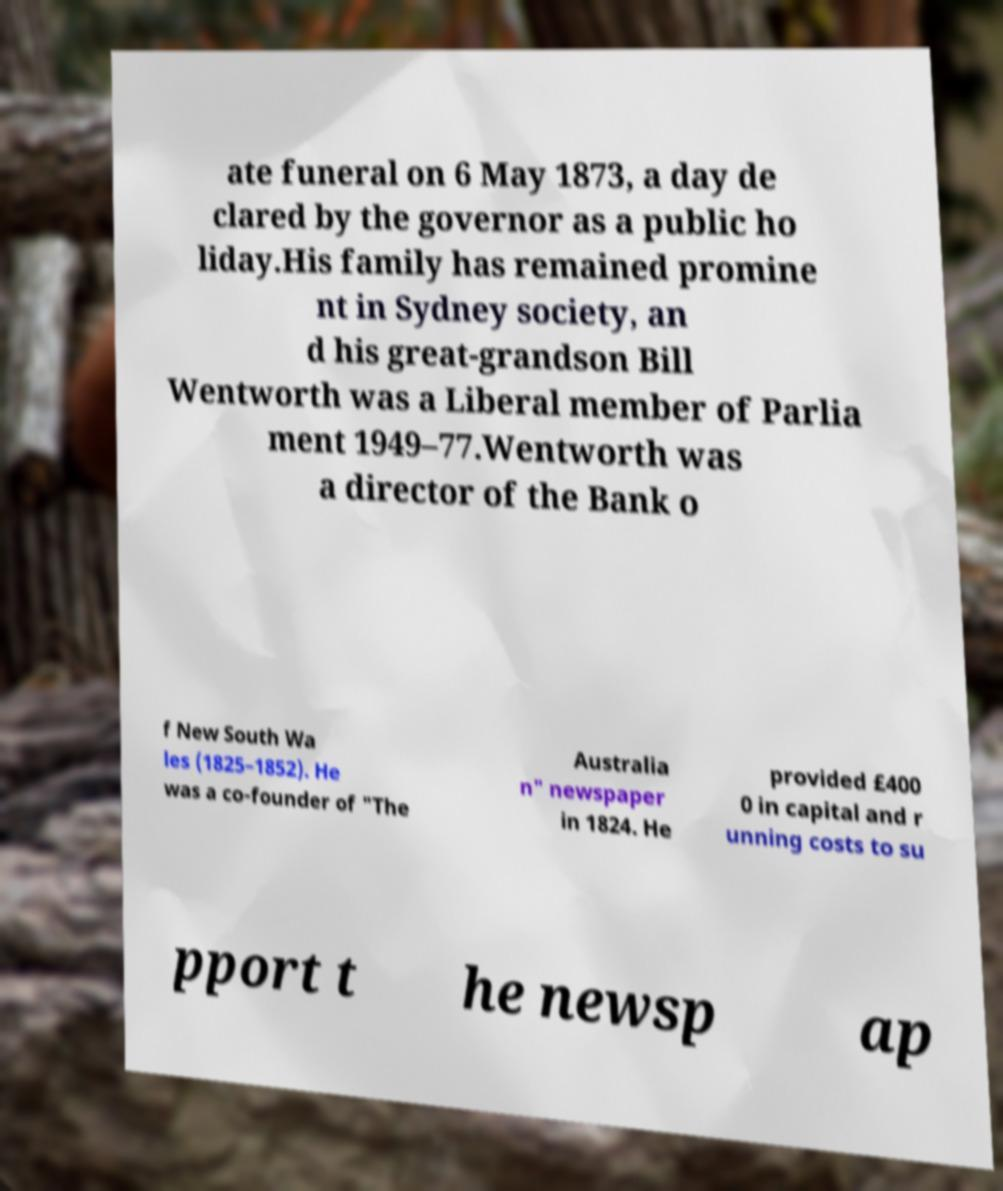What messages or text are displayed in this image? I need them in a readable, typed format. ate funeral on 6 May 1873, a day de clared by the governor as a public ho liday.His family has remained promine nt in Sydney society, an d his great-grandson Bill Wentworth was a Liberal member of Parlia ment 1949–77.Wentworth was a director of the Bank o f New South Wa les (1825–1852). He was a co-founder of "The Australia n" newspaper in 1824. He provided £400 0 in capital and r unning costs to su pport t he newsp ap 